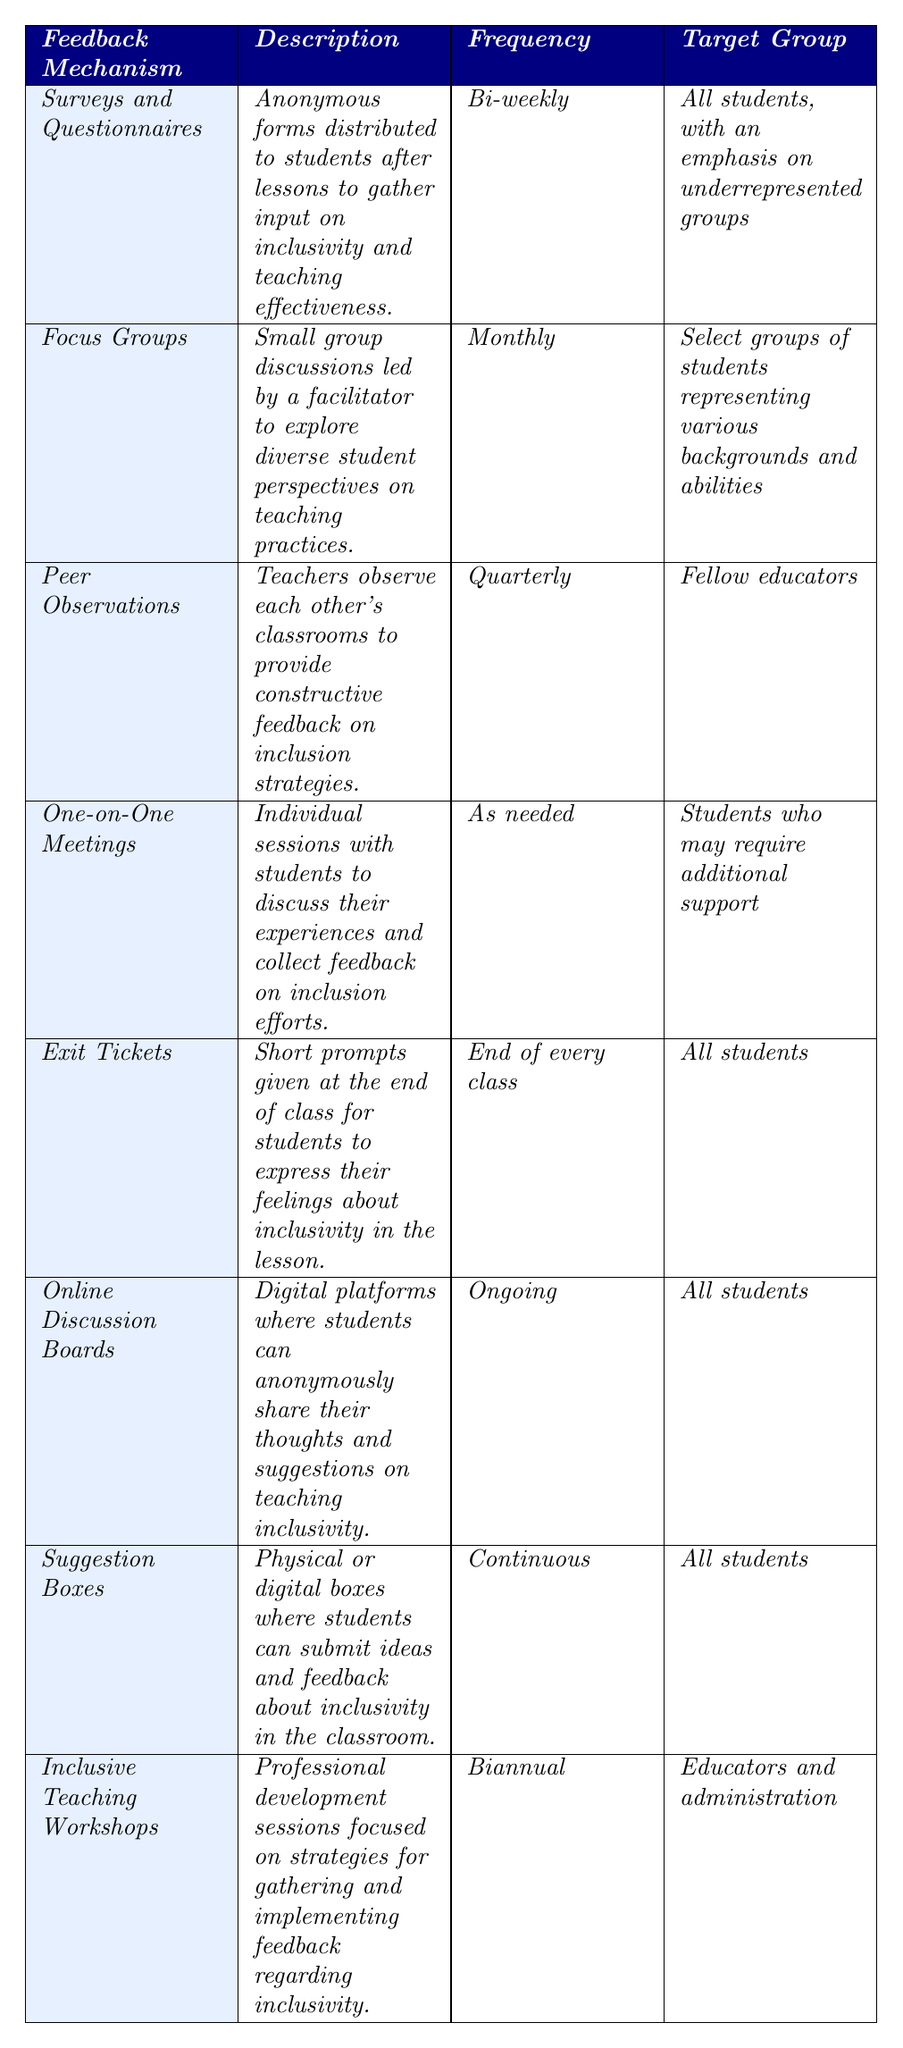What is the frequency of the "Surveys and Questionnaires"? The table states that "Surveys and Questionnaires" are conducted bi-weekly.
Answer: Bi-weekly Which feedback mechanism has a frequency of "End of every class"? The table shows "Exit Tickets" are given at the end of every class as a feedback mechanism.
Answer: Exit Tickets Are "Peer Observations" aimed at students? The table specifies that "Peer Observations" target fellow educators, not students.
Answer: No How many feedback mechanisms have a frequency of "Ongoing"? The table lists "Online Discussion Boards" as the only feedback mechanism with an ongoing frequency.
Answer: 1 What feedback mechanism targets "Students who may require additional support"? The table indicates that "One-on-One Meetings" are designed for students needing additional support.
Answer: One-on-One Meetings List all the feedback mechanisms that include "all students" as their target group. The table lists "Surveys and Questionnaires," "Exit Tickets," "Online Discussion Boards," and "Suggestion Boxes" as feedback mechanisms targeting all students.
Answer: Surveys and Questionnaires, Exit Tickets, Online Discussion Boards, Suggestion Boxes What is the difference in frequency between "Focus Groups" and "Inclusive Teaching Workshops"? "Focus Groups" occur monthly and "Inclusive Teaching Workshops" biannually; since there are 6 months in half a year, the difference is 6 - 1 = 5 months.
Answer: 5 months Which feedback mechanism occurs most frequently, and what is that frequency? "Exit Tickets" occur at the end of every class, which is more frequent than any other listed mechanism.
Answer: End of every class If a teacher observes their peers quarterly and then conducts an inclusive teaching workshop biannually, how many feedback mechanisms would the teacher engage in over one year? In a year, the teacher would observe peers 4 times and conduct workshops 2 times, totaling 4 + 2 = 6 engagements.
Answer: 6 Are there any feedback mechanisms aimed exclusively at educators? The only feedback mechanism that targets educators is "Inclusive Teaching Workshops."
Answer: Yes 